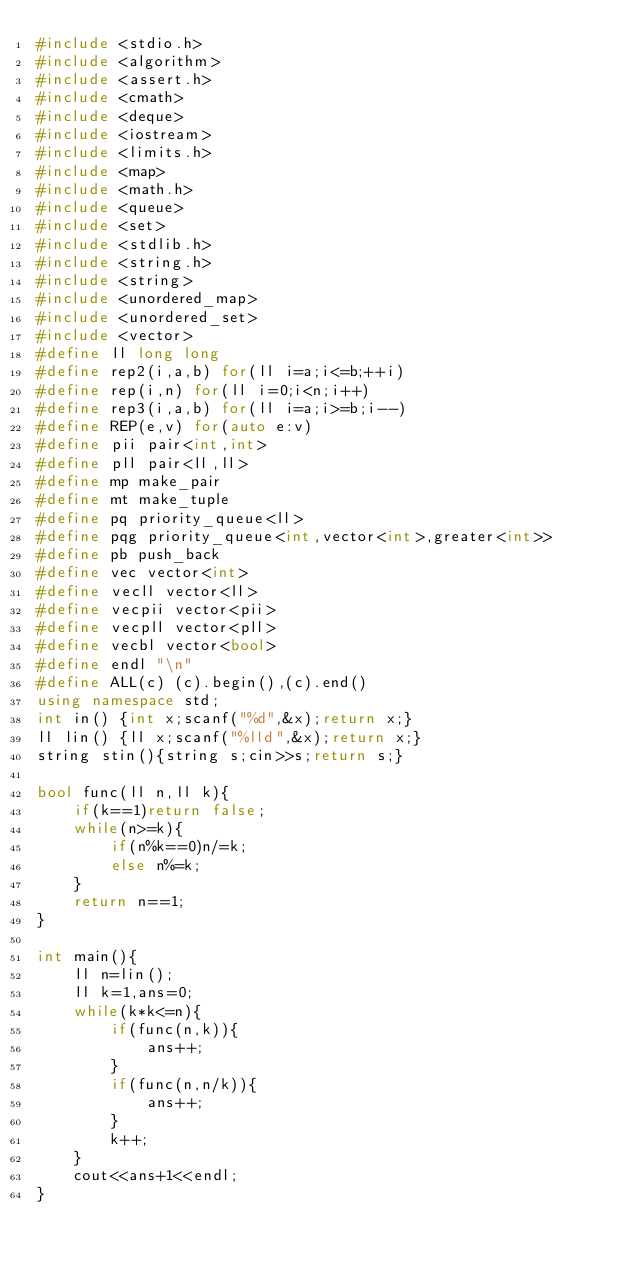Convert code to text. <code><loc_0><loc_0><loc_500><loc_500><_C++_>#include <stdio.h>
#include <algorithm>
#include <assert.h>
#include <cmath>
#include <deque>
#include <iostream>
#include <limits.h>
#include <map>
#include <math.h>
#include <queue>
#include <set>
#include <stdlib.h>
#include <string.h>
#include <string>
#include <unordered_map>
#include <unordered_set>
#include <vector>
#define ll long long
#define rep2(i,a,b) for(ll i=a;i<=b;++i)
#define rep(i,n) for(ll i=0;i<n;i++)
#define rep3(i,a,b) for(ll i=a;i>=b;i--)
#define REP(e,v) for(auto e:v)
#define pii pair<int,int>
#define pll pair<ll,ll>
#define mp make_pair
#define mt make_tuple
#define pq priority_queue<ll>
#define pqg priority_queue<int,vector<int>,greater<int>>
#define pb push_back
#define vec vector<int>
#define vecll vector<ll>
#define vecpii vector<pii>
#define vecpll vector<pll>
#define vecbl vector<bool>
#define endl "\n"
#define ALL(c) (c).begin(),(c).end()
using namespace std;
int in() {int x;scanf("%d",&x);return x;}
ll lin() {ll x;scanf("%lld",&x);return x;}
string stin(){string s;cin>>s;return s;}

bool func(ll n,ll k){
    if(k==1)return false;
    while(n>=k){
        if(n%k==0)n/=k;
        else n%=k;
    }
    return n==1;
}

int main(){
    ll n=lin();
    ll k=1,ans=0;
    while(k*k<=n){
        if(func(n,k)){
            ans++;
        }
        if(func(n,n/k)){
            ans++;
        }
        k++;
    }
    cout<<ans+1<<endl;
}

</code> 